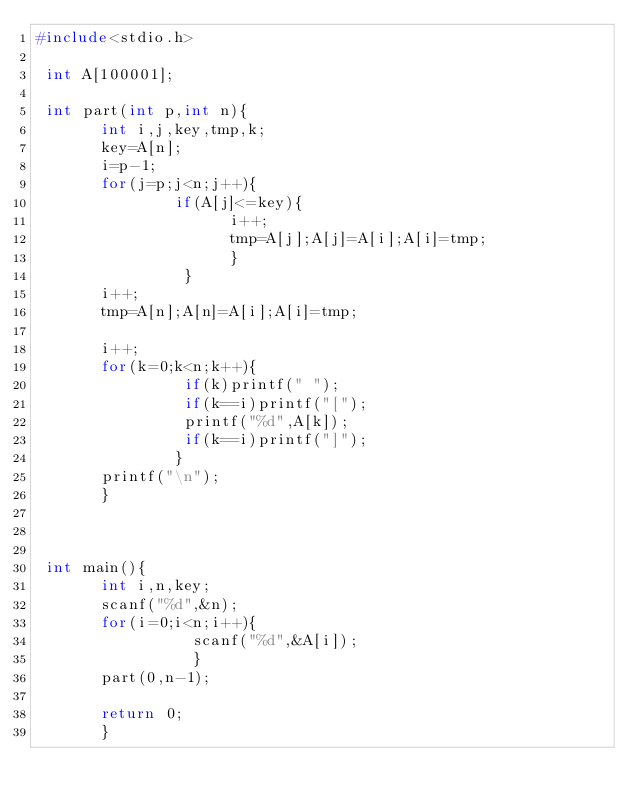Convert code to text. <code><loc_0><loc_0><loc_500><loc_500><_C_>#include<stdio.h>

 int A[100001];

 int part(int p,int n){
       int i,j,key,tmp,k;
       key=A[n];
       i=p-1;
       for(j=p;j<n;j++){
               if(A[j]<=key){
                     i++;
                     tmp=A[j];A[j]=A[i];A[i]=tmp;
                     }
                }
       i++;
       tmp=A[n];A[n]=A[i];A[i]=tmp;

       i++;
       for(k=0;k<n;k++){
                if(k)printf(" ");
                if(k==i)printf("[");
                printf("%d",A[k]);
                if(k==i)printf("]");
               }
       printf("\n");
       }
       
                

 int main(){
       int i,n,key;
       scanf("%d",&n);
       for(i=0;i<n;i++){
                 scanf("%d",&A[i]);
                 }
       part(0,n-1);

       return 0;
       }


</code> 